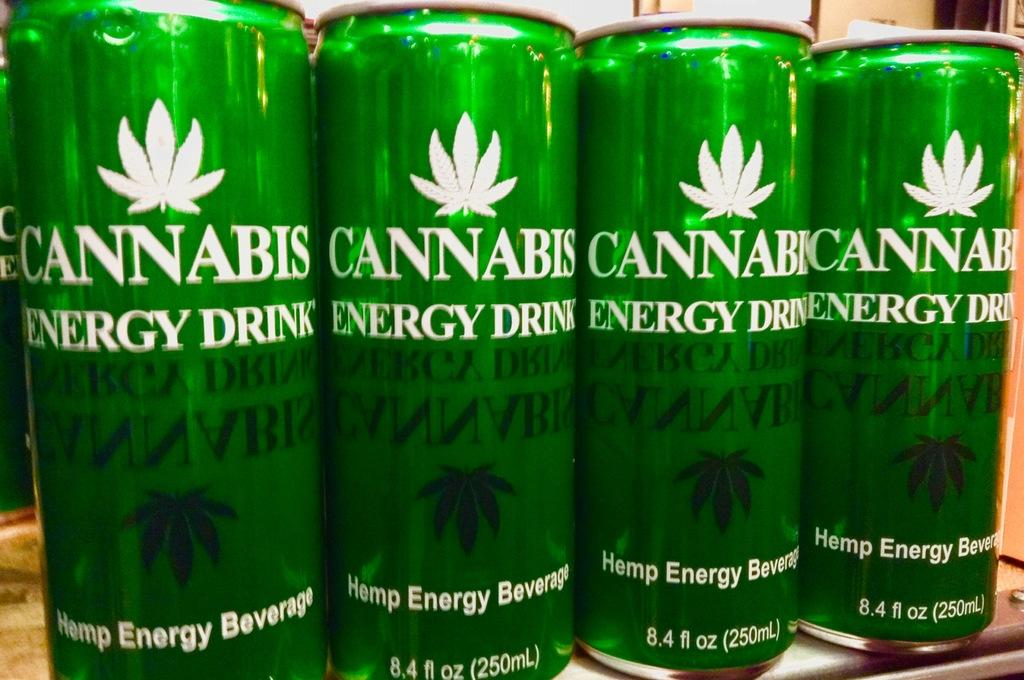What color are the tins on the table in the image? The tins on the table are green. What can be found on the tins? There is text on the tins. What can be seen in the background of the image? There is a wall in the background of the image. Is there a dog wearing a sweater in the image? No, there is no dog or sweater present in the image. 